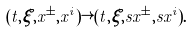<formula> <loc_0><loc_0><loc_500><loc_500>( t , \xi , x ^ { \pm } , x ^ { i } ) \rightarrow ( t , \xi , s x ^ { \pm } , s x ^ { i } ) .</formula> 